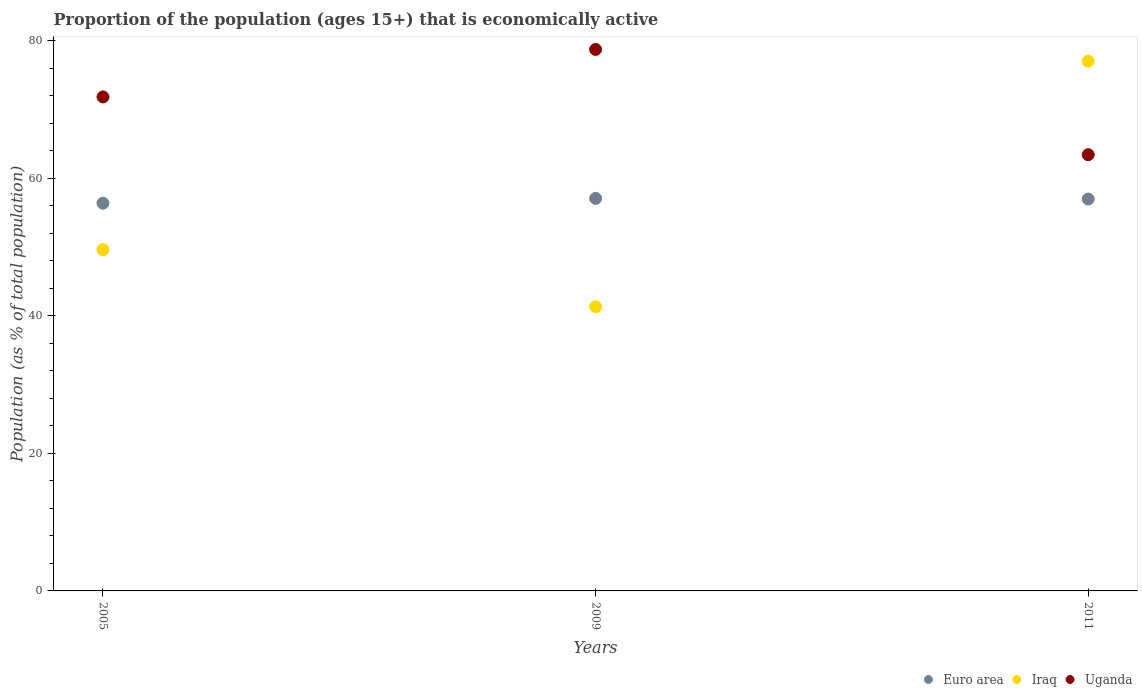How many different coloured dotlines are there?
Offer a terse response. 3. What is the proportion of the population that is economically active in Uganda in 2009?
Make the answer very short. 78.7. Across all years, what is the maximum proportion of the population that is economically active in Uganda?
Your answer should be compact. 78.7. Across all years, what is the minimum proportion of the population that is economically active in Uganda?
Your response must be concise. 63.4. In which year was the proportion of the population that is economically active in Uganda minimum?
Your response must be concise. 2011. What is the total proportion of the population that is economically active in Uganda in the graph?
Keep it short and to the point. 213.9. What is the difference between the proportion of the population that is economically active in Uganda in 2005 and that in 2011?
Keep it short and to the point. 8.4. What is the difference between the proportion of the population that is economically active in Uganda in 2011 and the proportion of the population that is economically active in Iraq in 2005?
Provide a succinct answer. 13.8. What is the average proportion of the population that is economically active in Iraq per year?
Offer a terse response. 55.97. In the year 2011, what is the difference between the proportion of the population that is economically active in Uganda and proportion of the population that is economically active in Euro area?
Your answer should be compact. 6.45. In how many years, is the proportion of the population that is economically active in Euro area greater than 68 %?
Your answer should be very brief. 0. What is the ratio of the proportion of the population that is economically active in Iraq in 2005 to that in 2011?
Your answer should be compact. 0.64. Is the difference between the proportion of the population that is economically active in Uganda in 2005 and 2011 greater than the difference between the proportion of the population that is economically active in Euro area in 2005 and 2011?
Your answer should be compact. Yes. What is the difference between the highest and the second highest proportion of the population that is economically active in Iraq?
Provide a short and direct response. 27.4. What is the difference between the highest and the lowest proportion of the population that is economically active in Uganda?
Offer a very short reply. 15.3. In how many years, is the proportion of the population that is economically active in Iraq greater than the average proportion of the population that is economically active in Iraq taken over all years?
Give a very brief answer. 1. Is the sum of the proportion of the population that is economically active in Euro area in 2005 and 2011 greater than the maximum proportion of the population that is economically active in Uganda across all years?
Keep it short and to the point. Yes. How many years are there in the graph?
Keep it short and to the point. 3. What is the difference between two consecutive major ticks on the Y-axis?
Provide a short and direct response. 20. Are the values on the major ticks of Y-axis written in scientific E-notation?
Give a very brief answer. No. Does the graph contain any zero values?
Keep it short and to the point. No. Does the graph contain grids?
Make the answer very short. No. How many legend labels are there?
Make the answer very short. 3. What is the title of the graph?
Provide a succinct answer. Proportion of the population (ages 15+) that is economically active. Does "Virgin Islands" appear as one of the legend labels in the graph?
Your answer should be very brief. No. What is the label or title of the X-axis?
Offer a very short reply. Years. What is the label or title of the Y-axis?
Ensure brevity in your answer.  Population (as % of total population). What is the Population (as % of total population) of Euro area in 2005?
Your answer should be compact. 56.35. What is the Population (as % of total population) of Iraq in 2005?
Keep it short and to the point. 49.6. What is the Population (as % of total population) of Uganda in 2005?
Ensure brevity in your answer.  71.8. What is the Population (as % of total population) of Euro area in 2009?
Provide a short and direct response. 57.05. What is the Population (as % of total population) in Iraq in 2009?
Your response must be concise. 41.3. What is the Population (as % of total population) in Uganda in 2009?
Keep it short and to the point. 78.7. What is the Population (as % of total population) in Euro area in 2011?
Ensure brevity in your answer.  56.95. What is the Population (as % of total population) of Uganda in 2011?
Provide a succinct answer. 63.4. Across all years, what is the maximum Population (as % of total population) of Euro area?
Offer a terse response. 57.05. Across all years, what is the maximum Population (as % of total population) of Uganda?
Provide a succinct answer. 78.7. Across all years, what is the minimum Population (as % of total population) of Euro area?
Provide a succinct answer. 56.35. Across all years, what is the minimum Population (as % of total population) of Iraq?
Offer a very short reply. 41.3. Across all years, what is the minimum Population (as % of total population) in Uganda?
Provide a succinct answer. 63.4. What is the total Population (as % of total population) of Euro area in the graph?
Keep it short and to the point. 170.36. What is the total Population (as % of total population) in Iraq in the graph?
Make the answer very short. 167.9. What is the total Population (as % of total population) in Uganda in the graph?
Your answer should be compact. 213.9. What is the difference between the Population (as % of total population) in Euro area in 2005 and that in 2009?
Your answer should be compact. -0.7. What is the difference between the Population (as % of total population) of Uganda in 2005 and that in 2009?
Give a very brief answer. -6.9. What is the difference between the Population (as % of total population) of Euro area in 2005 and that in 2011?
Offer a very short reply. -0.6. What is the difference between the Population (as % of total population) of Iraq in 2005 and that in 2011?
Ensure brevity in your answer.  -27.4. What is the difference between the Population (as % of total population) of Uganda in 2005 and that in 2011?
Keep it short and to the point. 8.4. What is the difference between the Population (as % of total population) in Euro area in 2009 and that in 2011?
Your response must be concise. 0.1. What is the difference between the Population (as % of total population) of Iraq in 2009 and that in 2011?
Provide a short and direct response. -35.7. What is the difference between the Population (as % of total population) in Euro area in 2005 and the Population (as % of total population) in Iraq in 2009?
Keep it short and to the point. 15.05. What is the difference between the Population (as % of total population) in Euro area in 2005 and the Population (as % of total population) in Uganda in 2009?
Keep it short and to the point. -22.34. What is the difference between the Population (as % of total population) in Iraq in 2005 and the Population (as % of total population) in Uganda in 2009?
Give a very brief answer. -29.1. What is the difference between the Population (as % of total population) in Euro area in 2005 and the Population (as % of total population) in Iraq in 2011?
Give a very brief answer. -20.64. What is the difference between the Population (as % of total population) of Euro area in 2005 and the Population (as % of total population) of Uganda in 2011?
Make the answer very short. -7.04. What is the difference between the Population (as % of total population) in Euro area in 2009 and the Population (as % of total population) in Iraq in 2011?
Offer a terse response. -19.95. What is the difference between the Population (as % of total population) of Euro area in 2009 and the Population (as % of total population) of Uganda in 2011?
Your answer should be very brief. -6.35. What is the difference between the Population (as % of total population) of Iraq in 2009 and the Population (as % of total population) of Uganda in 2011?
Provide a succinct answer. -22.1. What is the average Population (as % of total population) of Euro area per year?
Your response must be concise. 56.79. What is the average Population (as % of total population) of Iraq per year?
Provide a short and direct response. 55.97. What is the average Population (as % of total population) in Uganda per year?
Give a very brief answer. 71.3. In the year 2005, what is the difference between the Population (as % of total population) in Euro area and Population (as % of total population) in Iraq?
Offer a terse response. 6.75. In the year 2005, what is the difference between the Population (as % of total population) of Euro area and Population (as % of total population) of Uganda?
Ensure brevity in your answer.  -15.45. In the year 2005, what is the difference between the Population (as % of total population) in Iraq and Population (as % of total population) in Uganda?
Offer a very short reply. -22.2. In the year 2009, what is the difference between the Population (as % of total population) in Euro area and Population (as % of total population) in Iraq?
Provide a short and direct response. 15.75. In the year 2009, what is the difference between the Population (as % of total population) of Euro area and Population (as % of total population) of Uganda?
Provide a short and direct response. -21.65. In the year 2009, what is the difference between the Population (as % of total population) of Iraq and Population (as % of total population) of Uganda?
Provide a short and direct response. -37.4. In the year 2011, what is the difference between the Population (as % of total population) of Euro area and Population (as % of total population) of Iraq?
Your answer should be compact. -20.05. In the year 2011, what is the difference between the Population (as % of total population) of Euro area and Population (as % of total population) of Uganda?
Give a very brief answer. -6.45. What is the ratio of the Population (as % of total population) of Euro area in 2005 to that in 2009?
Ensure brevity in your answer.  0.99. What is the ratio of the Population (as % of total population) of Iraq in 2005 to that in 2009?
Your answer should be compact. 1.2. What is the ratio of the Population (as % of total population) of Uganda in 2005 to that in 2009?
Offer a very short reply. 0.91. What is the ratio of the Population (as % of total population) of Euro area in 2005 to that in 2011?
Your response must be concise. 0.99. What is the ratio of the Population (as % of total population) of Iraq in 2005 to that in 2011?
Offer a very short reply. 0.64. What is the ratio of the Population (as % of total population) of Uganda in 2005 to that in 2011?
Provide a succinct answer. 1.13. What is the ratio of the Population (as % of total population) of Iraq in 2009 to that in 2011?
Provide a succinct answer. 0.54. What is the ratio of the Population (as % of total population) in Uganda in 2009 to that in 2011?
Offer a terse response. 1.24. What is the difference between the highest and the second highest Population (as % of total population) in Euro area?
Give a very brief answer. 0.1. What is the difference between the highest and the second highest Population (as % of total population) of Iraq?
Offer a very short reply. 27.4. What is the difference between the highest and the second highest Population (as % of total population) in Uganda?
Your answer should be very brief. 6.9. What is the difference between the highest and the lowest Population (as % of total population) in Euro area?
Offer a very short reply. 0.7. What is the difference between the highest and the lowest Population (as % of total population) in Iraq?
Keep it short and to the point. 35.7. 